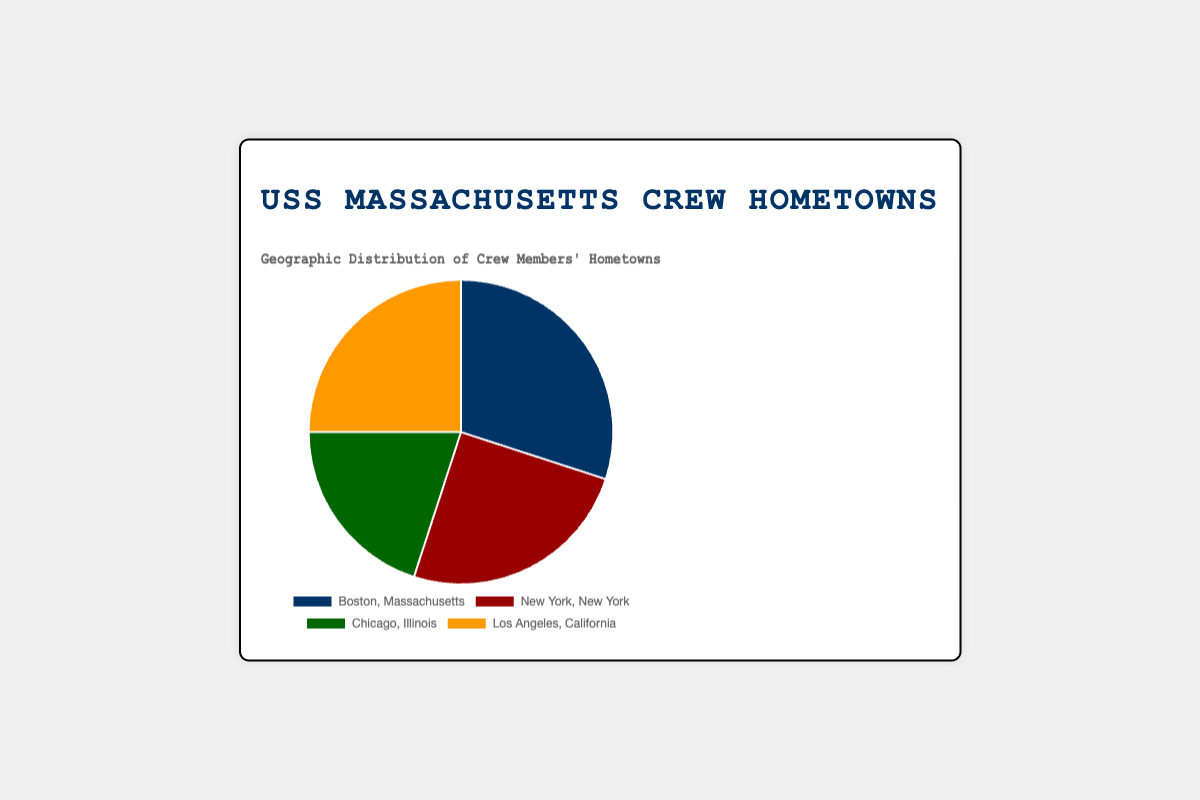What percentage of crew members' hometowns are from Boston, Massachusetts? The pie chart shows that 30% of the crew members are from Boston, Massachusetts.
Answer: 30% Which two cities have the same percentage of crew members' hometowns? By observing the pie chart, both New York, New York, and Los Angeles, California, represent 25% each of the crew members' hometowns.
Answer: New York, New York, and Los Angeles, California What is the combined percentage of crew members from Boston, Massachusetts, and Chicago, Illinois? The percentage of crew members from Boston, Massachusetts is 30%, and from Chicago, Illinois is 20%. Adding these together, 30% + 20% = 50%.
Answer: 50% Which hometown has the least representation among the crew members? The pie chart shows that Chicago, Illinois has the smallest segment, representing 20% of the crew members.
Answer: Chicago, Illinois Is the percentage of crew members from Los Angeles, California greater than that from Chicago, Illinois? The pie chart shows that Los Angeles, California has 25% while Chicago, Illinois has 20%. Since 25% is greater than 20%, the answer is yes.
Answer: Yes What is the average percentage of crew members from the four hometowns? To find the average percentage, sum the percentages of the four cities and then divide by 4. (30% + 25% + 20% + 25%) / 4 = 100% / 4 = 25%.
Answer: 25% What is the difference in percentage between New York, New York, and Chicago, Illinois? The pie chart shows that New York, New York has 25% and Chicago, Illinois has 20%. The difference is 25% - 20% = 5%.
Answer: 5% What is the total percentage of crew members from states other than Massachusetts? The crew members from outside Massachusetts are from New York, New York (25%), Chicago, Illinois (20%), and Los Angeles, California (25%). Adding these together, 25% + 20% + 25% = 70%.
Answer: 70% Which segment in the pie chart is represented by the color blue? The pie chart uses blue to represent Boston, Massachusetts.
Answer: Boston, Massachusetts Which city has a larger percentage of crew members, Boston, Massachusetts, or New York, New York? By comparing the segments in the pie chart, Boston, Massachusetts has 30% and New York, New York has 25%. Since 30% is larger than 25%, Boston has a larger percentage.
Answer: Boston, Massachusetts 